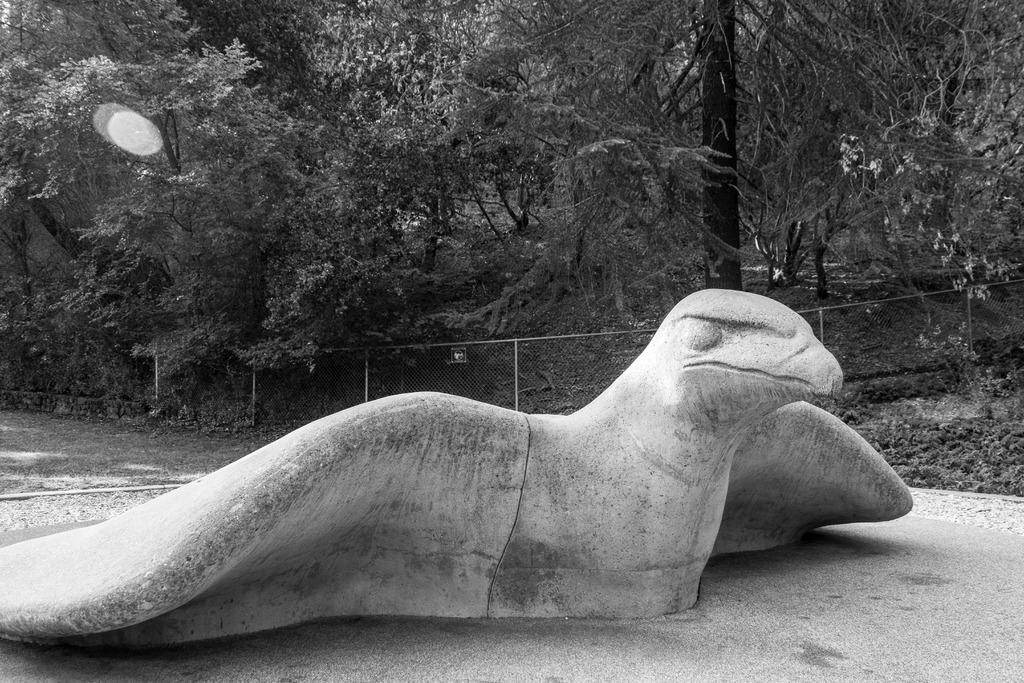What is the main subject of the image? There is a sculpture of a bird in the image. Where is the sculpture located? The sculpture is on a path. What type of vegetation can be seen in the image? There is grass, plants, and trees visible in the image. What architectural feature is present in the image? There is a railing in the image. Where is the faucet located in the image? There is no faucet present in the image. What type of park is depicted in the image? The image does not depict a park; it features a sculpture of a bird on a path with vegetation and a railing. 